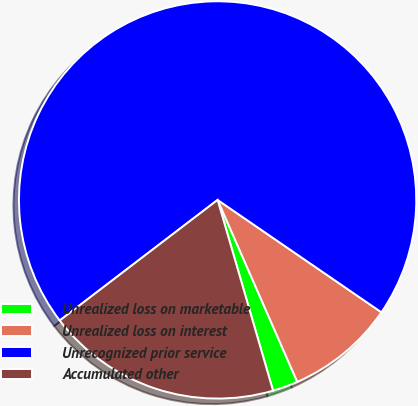Convert chart to OTSL. <chart><loc_0><loc_0><loc_500><loc_500><pie_chart><fcel>Unrealized loss on marketable<fcel>Unrealized loss on interest<fcel>Unrecognized prior service<fcel>Accumulated other<nl><fcel>2.07%<fcel>8.86%<fcel>69.95%<fcel>19.12%<nl></chart> 